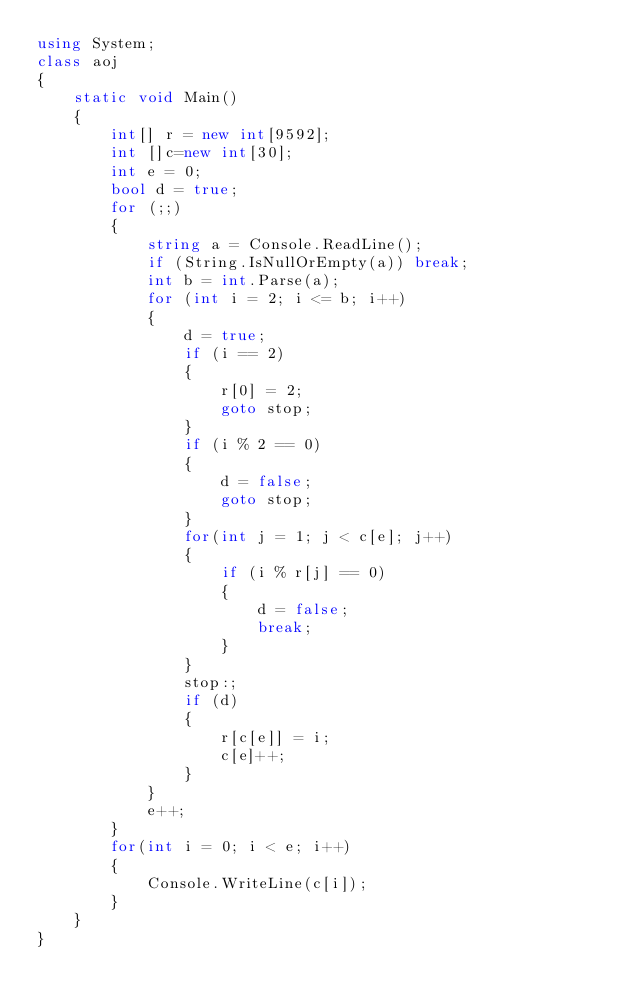<code> <loc_0><loc_0><loc_500><loc_500><_C#_>using System;
class aoj
{
    static void Main()
    {
        int[] r = new int[9592];
        int []c=new int[30];
        int e = 0;
        bool d = true;
        for (;;)
        {
            string a = Console.ReadLine();
            if (String.IsNullOrEmpty(a)) break;
            int b = int.Parse(a);
            for (int i = 2; i <= b; i++)
            {
                d = true;
                if (i == 2)
                {
                    r[0] = 2;
                    goto stop;
                }
                if (i % 2 == 0)
                {
                    d = false;
                    goto stop;
                }
                for(int j = 1; j < c[e]; j++)
                {
                    if (i % r[j] == 0)
                    {
                        d = false;
                        break;
                    }
                }
                stop:;
                if (d)
                {
                    r[c[e]] = i;
                    c[e]++;
                }
            }
            e++;
        }
        for(int i = 0; i < e; i++)
        {
            Console.WriteLine(c[i]);
        }
    }
}</code> 